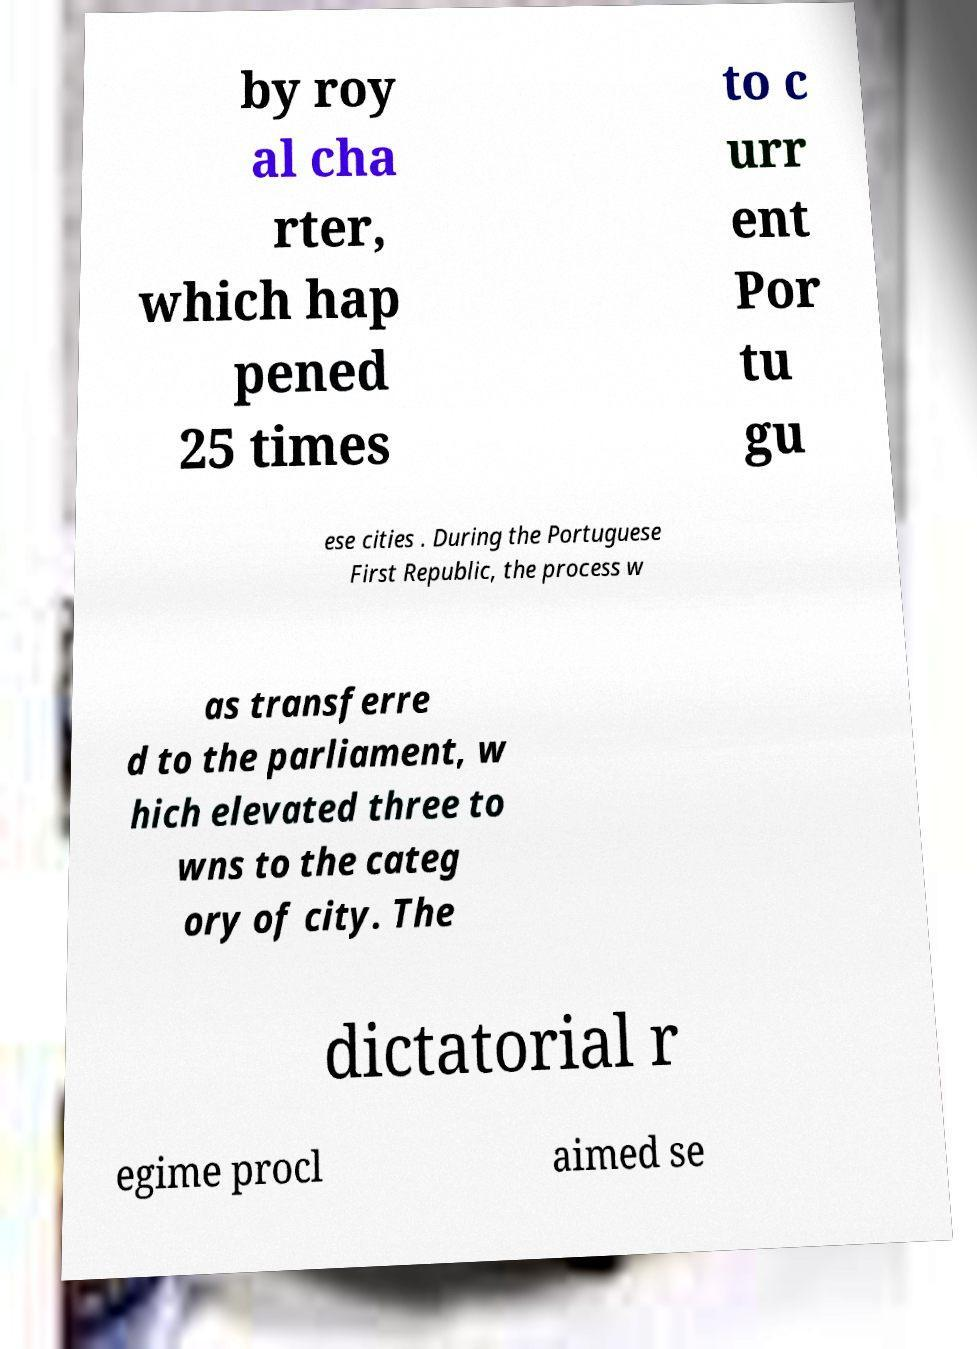Could you assist in decoding the text presented in this image and type it out clearly? by roy al cha rter, which hap pened 25 times to c urr ent Por tu gu ese cities . During the Portuguese First Republic, the process w as transferre d to the parliament, w hich elevated three to wns to the categ ory of city. The dictatorial r egime procl aimed se 